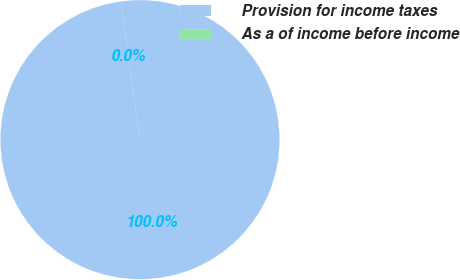Convert chart. <chart><loc_0><loc_0><loc_500><loc_500><pie_chart><fcel>Provision for income taxes<fcel>As a of income before income<nl><fcel>100.0%<fcel>0.0%<nl></chart> 